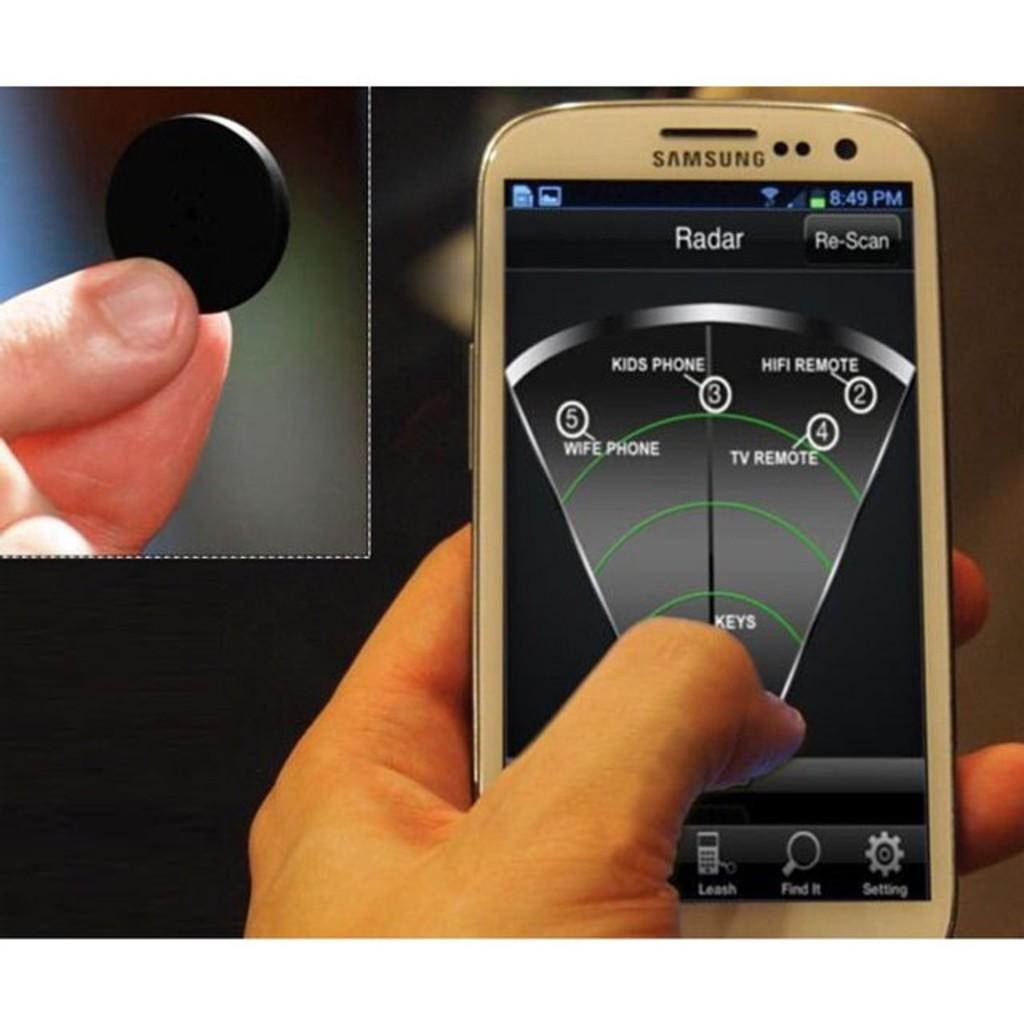<image>
Give a short and clear explanation of the subsequent image. a phone that says radar on the top 